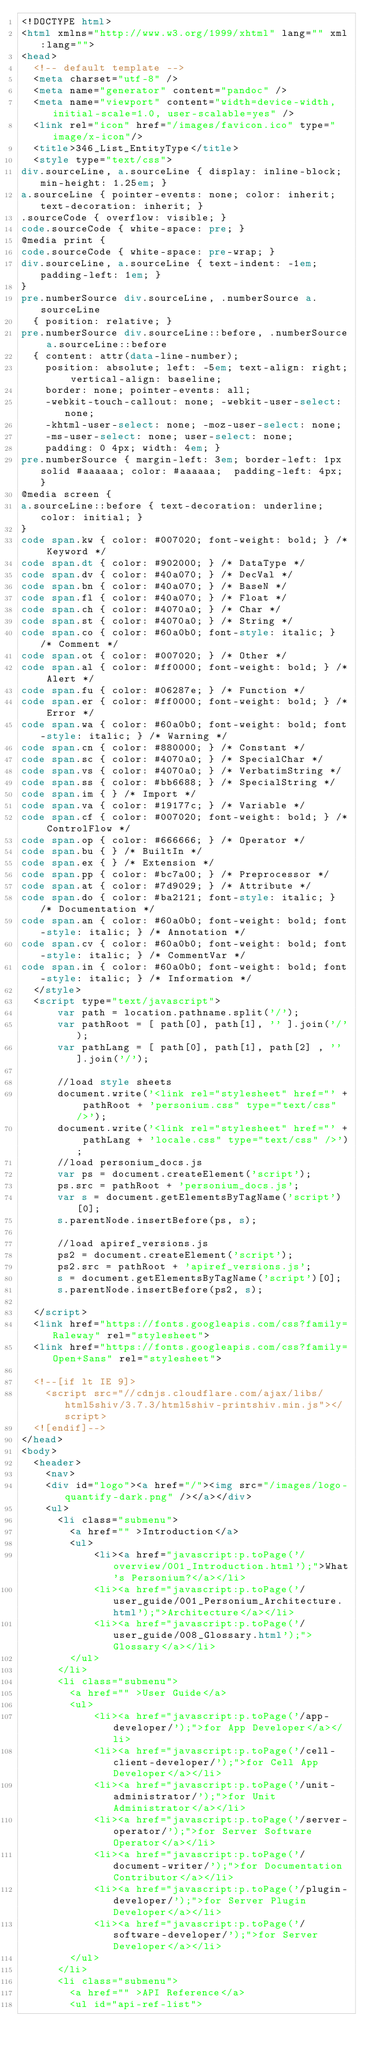Convert code to text. <code><loc_0><loc_0><loc_500><loc_500><_HTML_><!DOCTYPE html>
<html xmlns="http://www.w3.org/1999/xhtml" lang="" xml:lang="">
<head>
  <!-- default template -->
  <meta charset="utf-8" />
  <meta name="generator" content="pandoc" />
  <meta name="viewport" content="width=device-width, initial-scale=1.0, user-scalable=yes" />
  <link rel="icon" href="/images/favicon.ico" type="image/x-icon"/>
  <title>346_List_EntityType</title>
  <style type="text/css">
div.sourceLine, a.sourceLine { display: inline-block; min-height: 1.25em; }
a.sourceLine { pointer-events: none; color: inherit; text-decoration: inherit; }
.sourceCode { overflow: visible; }
code.sourceCode { white-space: pre; }
@media print {
code.sourceCode { white-space: pre-wrap; }
div.sourceLine, a.sourceLine { text-indent: -1em; padding-left: 1em; }
}
pre.numberSource div.sourceLine, .numberSource a.sourceLine
  { position: relative; }
pre.numberSource div.sourceLine::before, .numberSource a.sourceLine::before
  { content: attr(data-line-number);
    position: absolute; left: -5em; text-align: right; vertical-align: baseline;
    border: none; pointer-events: all;
    -webkit-touch-callout: none; -webkit-user-select: none;
    -khtml-user-select: none; -moz-user-select: none;
    -ms-user-select: none; user-select: none;
    padding: 0 4px; width: 4em; }
pre.numberSource { margin-left: 3em; border-left: 1px solid #aaaaaa; color: #aaaaaa;  padding-left: 4px; }
@media screen {
a.sourceLine::before { text-decoration: underline; color: initial; }
}
code span.kw { color: #007020; font-weight: bold; } /* Keyword */
code span.dt { color: #902000; } /* DataType */
code span.dv { color: #40a070; } /* DecVal */
code span.bn { color: #40a070; } /* BaseN */
code span.fl { color: #40a070; } /* Float */
code span.ch { color: #4070a0; } /* Char */
code span.st { color: #4070a0; } /* String */
code span.co { color: #60a0b0; font-style: italic; } /* Comment */
code span.ot { color: #007020; } /* Other */
code span.al { color: #ff0000; font-weight: bold; } /* Alert */
code span.fu { color: #06287e; } /* Function */
code span.er { color: #ff0000; font-weight: bold; } /* Error */
code span.wa { color: #60a0b0; font-weight: bold; font-style: italic; } /* Warning */
code span.cn { color: #880000; } /* Constant */
code span.sc { color: #4070a0; } /* SpecialChar */
code span.vs { color: #4070a0; } /* VerbatimString */
code span.ss { color: #bb6688; } /* SpecialString */
code span.im { } /* Import */
code span.va { color: #19177c; } /* Variable */
code span.cf { color: #007020; font-weight: bold; } /* ControlFlow */
code span.op { color: #666666; } /* Operator */
code span.bu { } /* BuiltIn */
code span.ex { } /* Extension */
code span.pp { color: #bc7a00; } /* Preprocessor */
code span.at { color: #7d9029; } /* Attribute */
code span.do { color: #ba2121; font-style: italic; } /* Documentation */
code span.an { color: #60a0b0; font-weight: bold; font-style: italic; } /* Annotation */
code span.cv { color: #60a0b0; font-weight: bold; font-style: italic; } /* CommentVar */
code span.in { color: #60a0b0; font-weight: bold; font-style: italic; } /* Information */
  </style>
  <script type="text/javascript">
      var path = location.pathname.split('/');
      var pathRoot = [ path[0], path[1], '' ].join('/');
      var pathLang = [ path[0], path[1], path[2] , ''].join('/');

      //load style sheets
      document.write('<link rel="stylesheet" href="' + pathRoot + 'personium.css" type="text/css" />');
      document.write('<link rel="stylesheet" href="' + pathLang + 'locale.css" type="text/css" />');
      //load personium_docs.js
      var ps = document.createElement('script');
      ps.src = pathRoot + 'personium_docs.js';
      var s = document.getElementsByTagName('script')[0];
      s.parentNode.insertBefore(ps, s);
    
      //load apiref_versions.js
      ps2 = document.createElement('script');
      ps2.src = pathRoot + 'apiref_versions.js';
      s = document.getElementsByTagName('script')[0];
      s.parentNode.insertBefore(ps2, s);

  </script>
  <link href="https://fonts.googleapis.com/css?family=Raleway" rel="stylesheet">
  <link href="https://fonts.googleapis.com/css?family=Open+Sans" rel="stylesheet">
  
  <!--[if lt IE 9]>
    <script src="//cdnjs.cloudflare.com/ajax/libs/html5shiv/3.7.3/html5shiv-printshiv.min.js"></script>
  <![endif]-->
</head>
<body>
  <header>
    <nav>
    <div id="logo"><a href="/"><img src="/images/logo-quantify-dark.png" /></a></div>
    <ul>
      <li class="submenu">
        <a href="" >Introduction</a>
        <ul>
            <li><a href="javascript:p.toPage('/overview/001_Introduction.html');">What's Personium?</a></li>
            <li><a href="javascript:p.toPage('/user_guide/001_Personium_Architecture.html');">Architecture</a></li>
            <li><a href="javascript:p.toPage('/user_guide/008_Glossary.html');">Glossary</a></li>
        </ul>
      </li>
      <li class="submenu">
        <a href="" >User Guide</a>
        <ul>
            <li><a href="javascript:p.toPage('/app-developer/');">for App Developer</a></li>
            <li><a href="javascript:p.toPage('/cell-client-developer/');">for Cell App Developer</a></li>
            <li><a href="javascript:p.toPage('/unit-administrator/');">for Unit Administrator</a></li>
            <li><a href="javascript:p.toPage('/server-operator/');">for Server Software Operator</a></li>
            <li><a href="javascript:p.toPage('/document-writer/');">for Documentation Contributor</a></li>
            <li><a href="javascript:p.toPage('/plugin-developer/');">for Server Plugin Developer</a></li>
            <li><a href="javascript:p.toPage('/software-developer/');">for Server Developer</a></li>
        </ul>
      </li>
      <li class="submenu">
        <a href="" >API Reference</a>
        <ul id="api-ref-list"></code> 